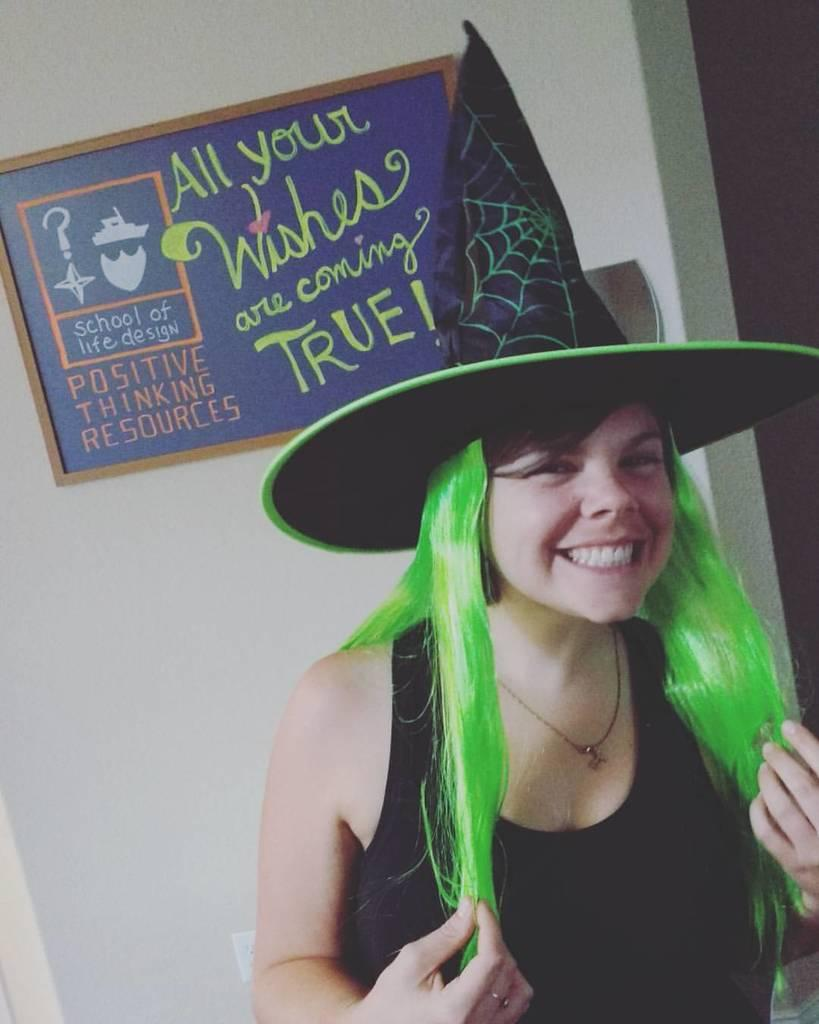What is the main subject of the image? There is a person in the image. What is the person's facial expression? The person is smiling. What type of clothing accessory is the person wearing? The person is wearing a hat. What can be seen in the background of the image? There is a frame attached to the wall in the background of the image. Is the person's temper visible in the image? There is no indication of the person's temper in the image, as it only shows the person smiling and wearing a hat. 